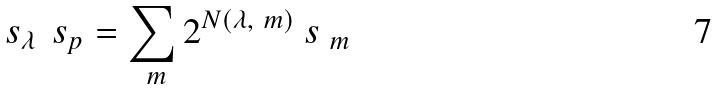<formula> <loc_0><loc_0><loc_500><loc_500>\ s _ { \lambda } \, \ s _ { p } = \sum _ { \ m } 2 ^ { N ( \lambda , \ m ) } \ s _ { \ m }</formula> 